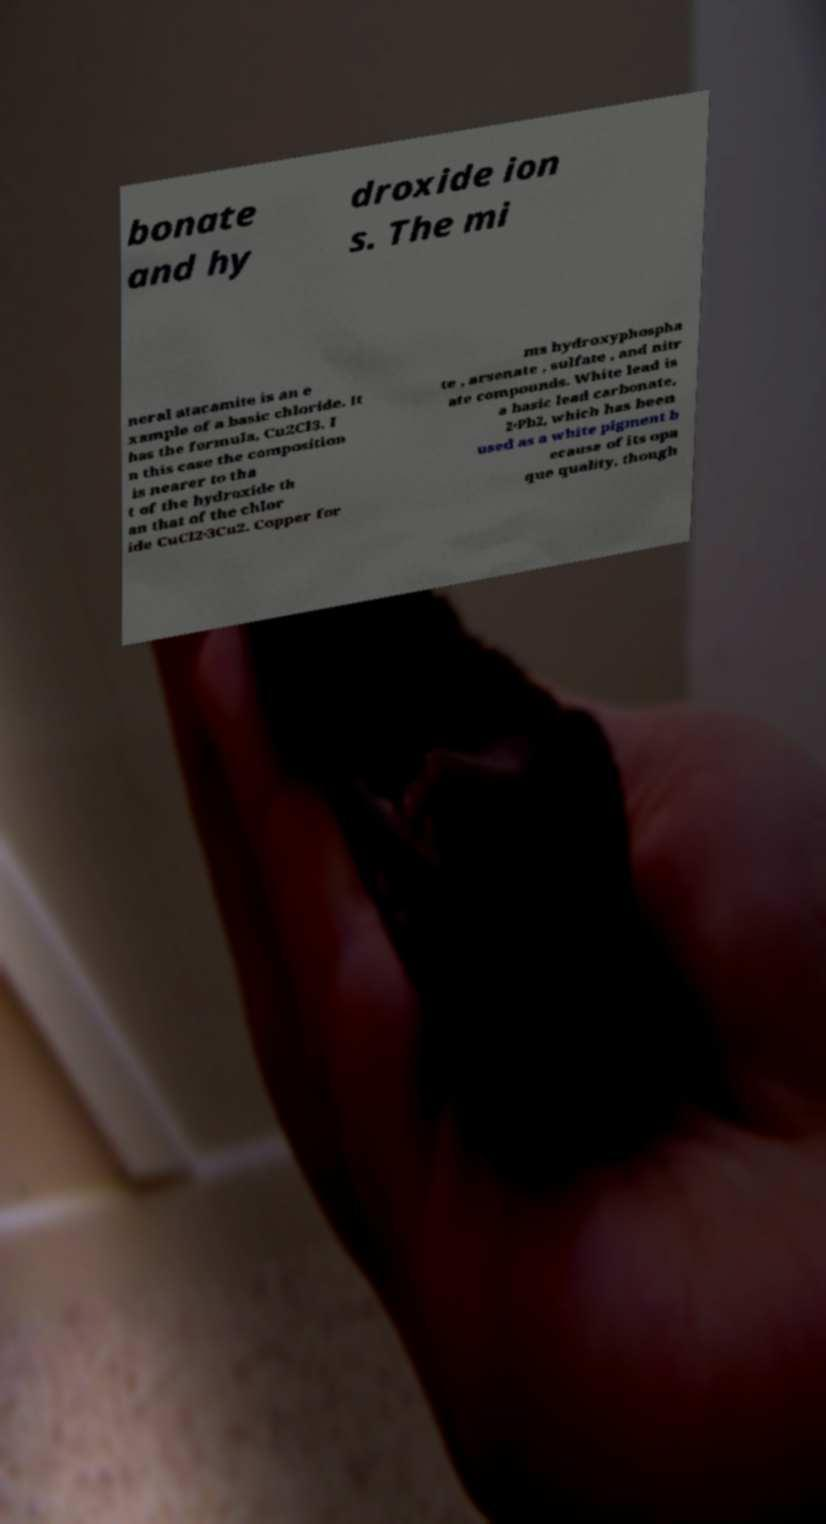I need the written content from this picture converted into text. Can you do that? bonate and hy droxide ion s. The mi neral atacamite is an e xample of a basic chloride. It has the formula, Cu2Cl3. I n this case the composition is nearer to tha t of the hydroxide th an that of the chlor ide CuCl2·3Cu2. Copper for ms hydroxyphospha te , arsenate , sulfate , and nitr ate compounds. White lead is a basic lead carbonate, 2·Pb2, which has been used as a white pigment b ecause of its opa que quality, though 